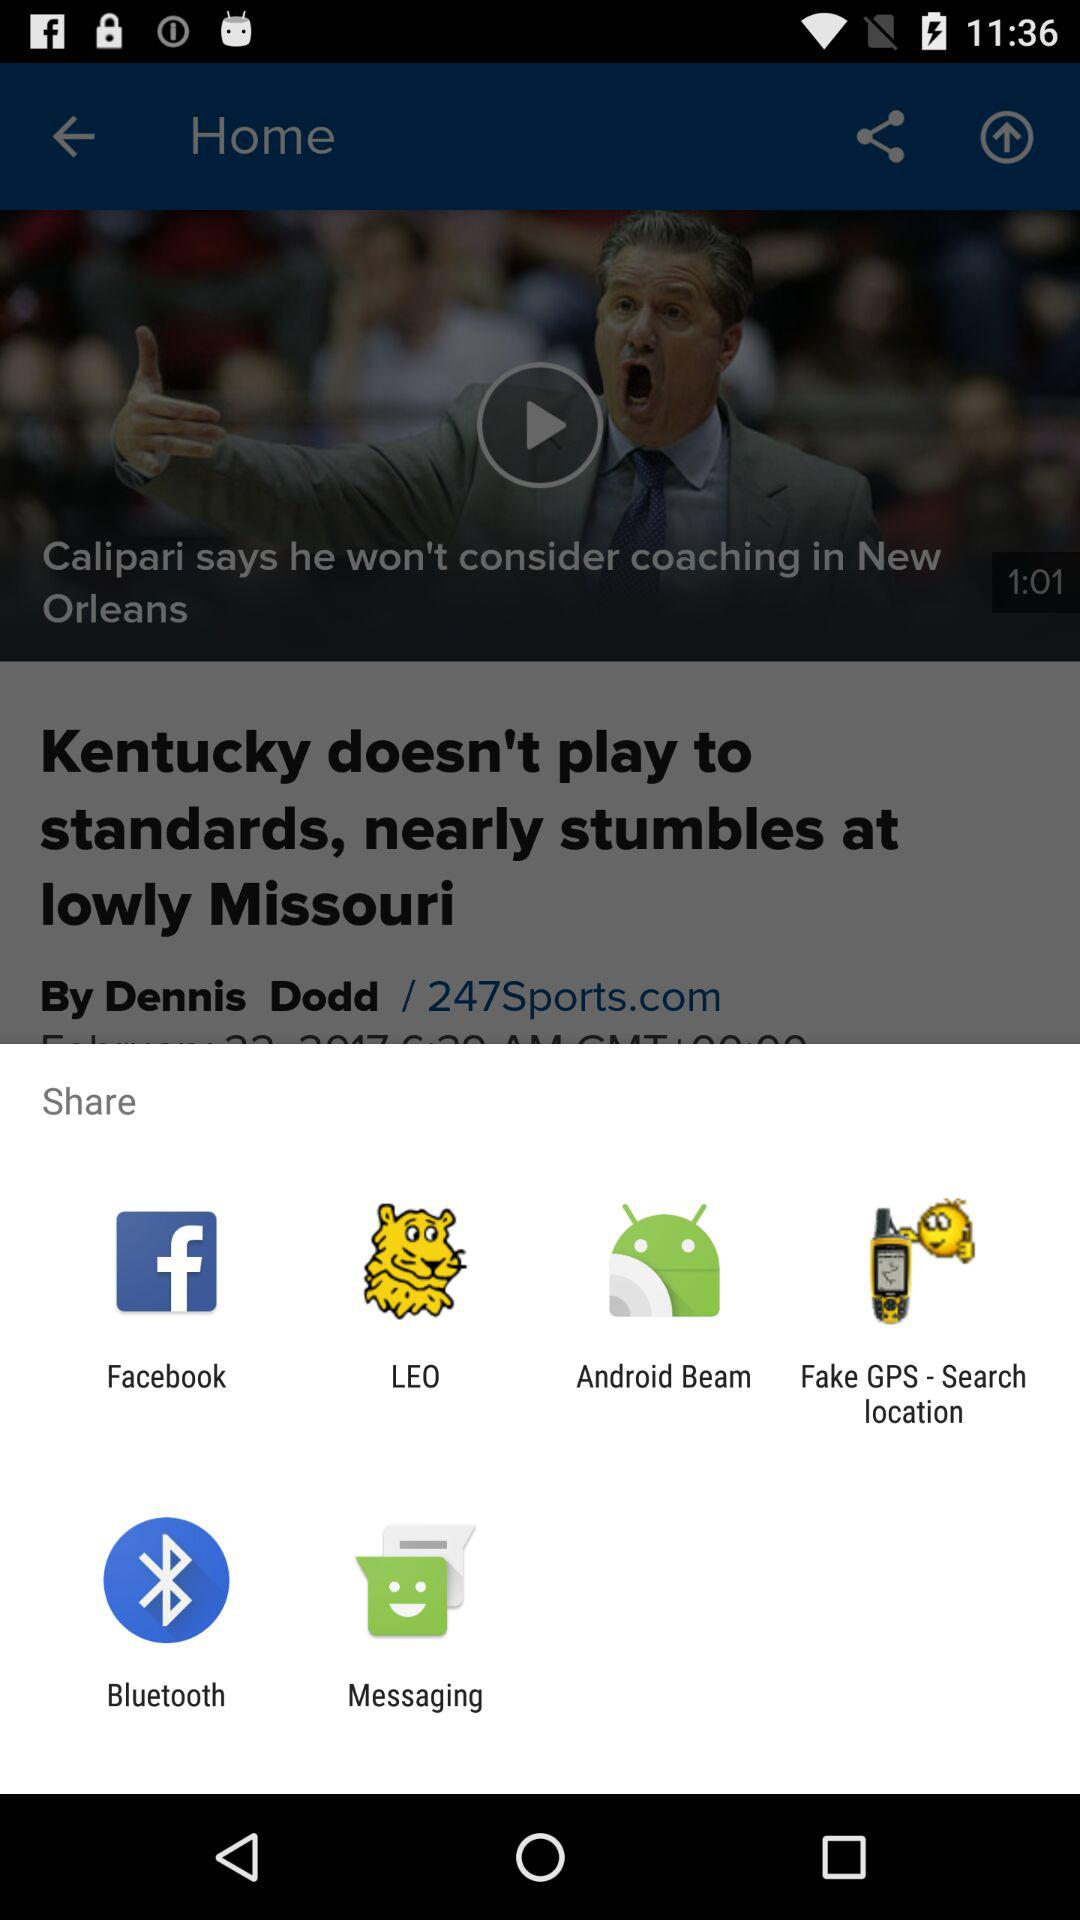Who posted the "Kentucky doesn't play to standards" news? The news was posted by Dennis Dodd. 